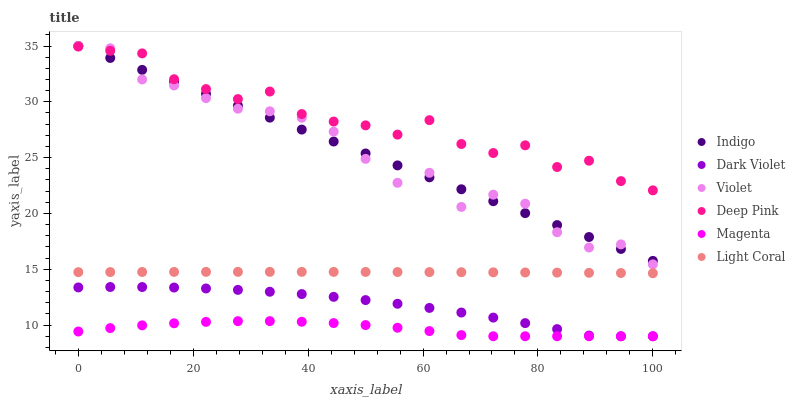Does Magenta have the minimum area under the curve?
Answer yes or no. Yes. Does Deep Pink have the maximum area under the curve?
Answer yes or no. Yes. Does Indigo have the minimum area under the curve?
Answer yes or no. No. Does Indigo have the maximum area under the curve?
Answer yes or no. No. Is Indigo the smoothest?
Answer yes or no. Yes. Is Violet the roughest?
Answer yes or no. Yes. Is Dark Violet the smoothest?
Answer yes or no. No. Is Dark Violet the roughest?
Answer yes or no. No. Does Dark Violet have the lowest value?
Answer yes or no. Yes. Does Indigo have the lowest value?
Answer yes or no. No. Does Violet have the highest value?
Answer yes or no. Yes. Does Dark Violet have the highest value?
Answer yes or no. No. Is Dark Violet less than Indigo?
Answer yes or no. Yes. Is Indigo greater than Dark Violet?
Answer yes or no. Yes. Does Violet intersect Deep Pink?
Answer yes or no. Yes. Is Violet less than Deep Pink?
Answer yes or no. No. Is Violet greater than Deep Pink?
Answer yes or no. No. Does Dark Violet intersect Indigo?
Answer yes or no. No. 